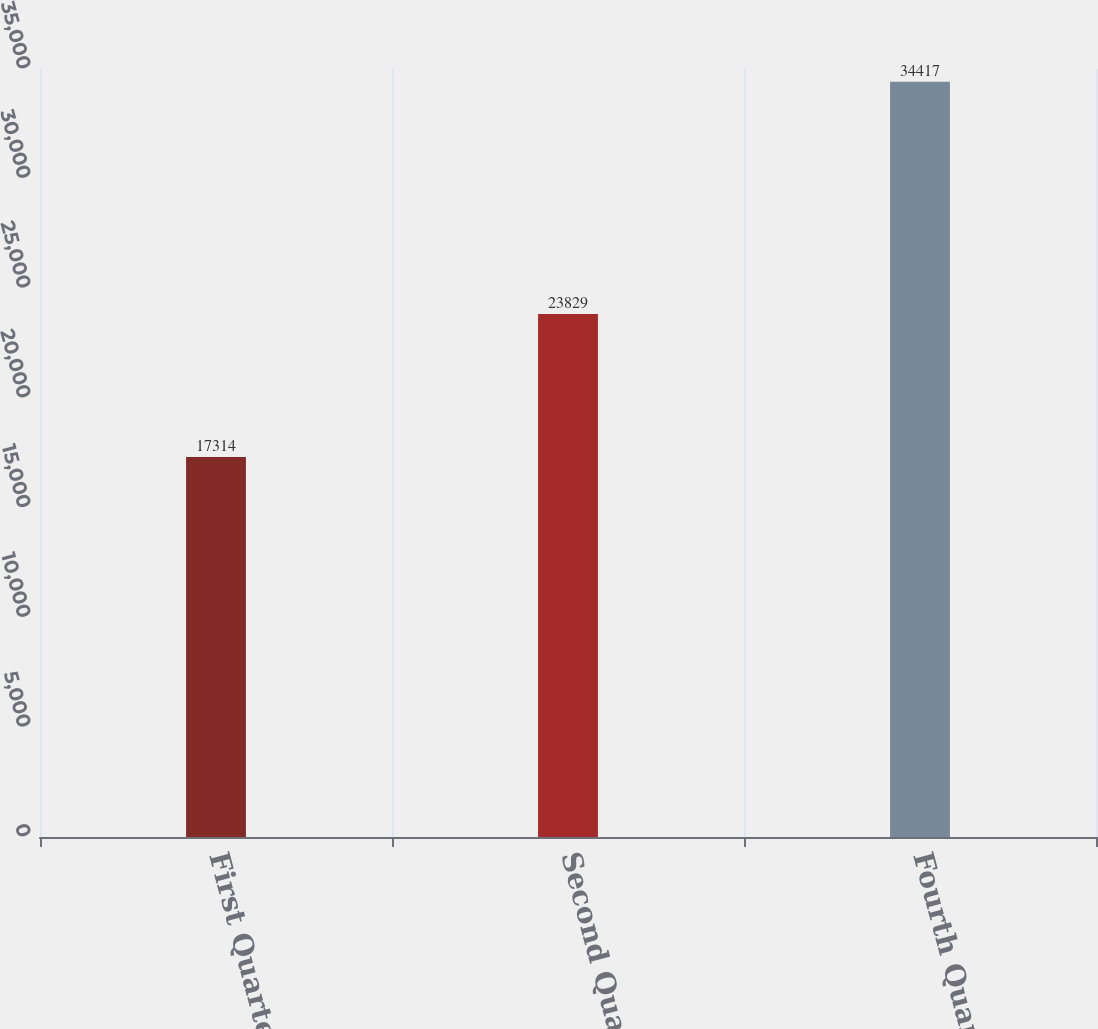Convert chart. <chart><loc_0><loc_0><loc_500><loc_500><bar_chart><fcel>First Quarter<fcel>Second Quarter<fcel>Fourth Quarter<nl><fcel>17314<fcel>23829<fcel>34417<nl></chart> 